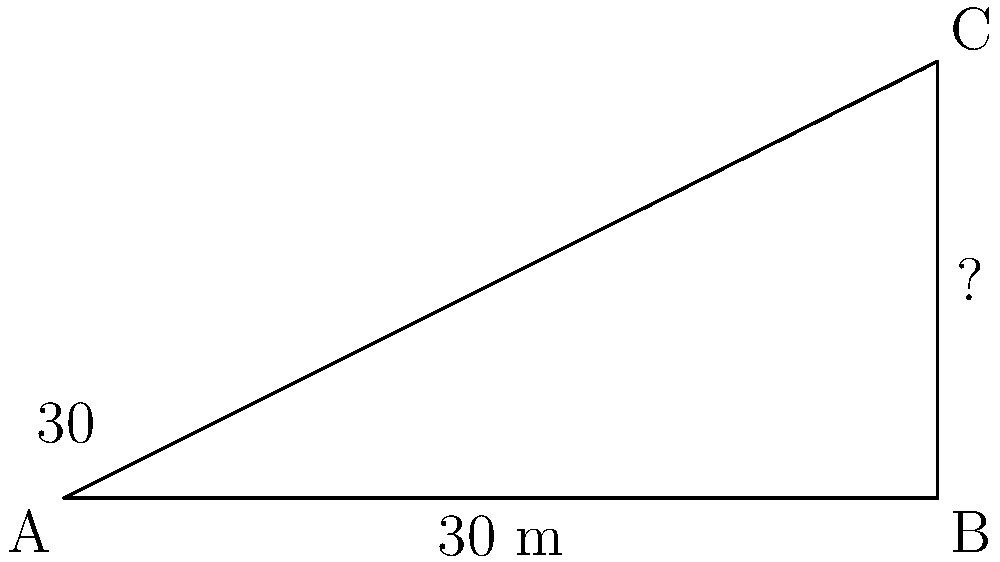In memory of your friend Harry Hawkins, who loved architecture, you decide to calculate the height of his favorite building. Standing 30 meters away from the base, you measure the angle of elevation to the top of the building to be 30°. What is the height of the building? Let's approach this step-by-step:

1) We can use the tangent function to solve this problem. The tangent of an angle in a right triangle is the ratio of the opposite side to the adjacent side.

2) In this case:
   - The angle is 30°
   - The adjacent side (distance from you to the building) is 30 meters
   - The opposite side (height of the building) is what we're trying to find

3) Let's call the height of the building $h$. We can write the equation:

   $\tan(30°) = \frac{h}{30}$

4) We know that $\tan(30°) = \frac{1}{\sqrt{3}} \approx 0.577$

5) Substituting this in:

   $0.577 = \frac{h}{30}$

6) To solve for $h$, multiply both sides by 30:

   $h = 0.577 \times 30 = 17.32$ meters

7) Rounding to the nearest meter:

   $h \approx 17$ meters
Answer: 17 meters 